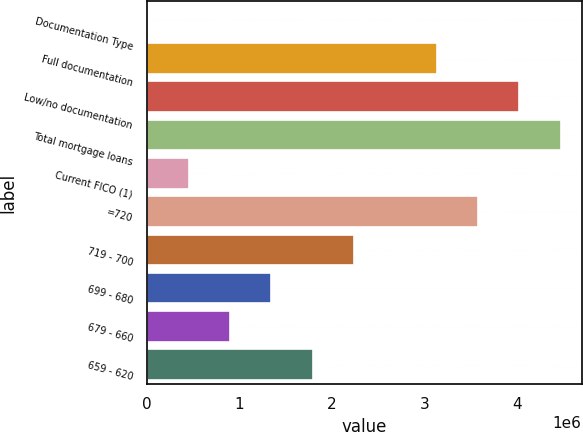<chart> <loc_0><loc_0><loc_500><loc_500><bar_chart><fcel>Documentation Type<fcel>Full documentation<fcel>Low/no documentation<fcel>Total mortgage loans<fcel>Current FICO (1)<fcel>=720<fcel>719 - 700<fcel>699 - 680<fcel>679 - 660<fcel>659 - 620<nl><fcel>2013<fcel>3.13296e+06<fcel>4.02751e+06<fcel>4.47479e+06<fcel>449291<fcel>3.58024e+06<fcel>2.2384e+06<fcel>1.34385e+06<fcel>896569<fcel>1.79112e+06<nl></chart> 